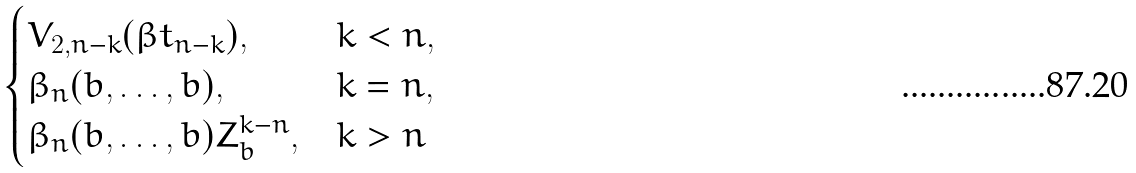<formula> <loc_0><loc_0><loc_500><loc_500>\begin{cases} V _ { 2 , n - k } ( \beta t _ { n - k } ) , & k < n , \\ \beta _ { n } ( b , \dots , b ) , & k = n , \\ \beta _ { n } ( b , \dots , b ) Z _ { b } ^ { k - n } , & k > n \end{cases}</formula> 